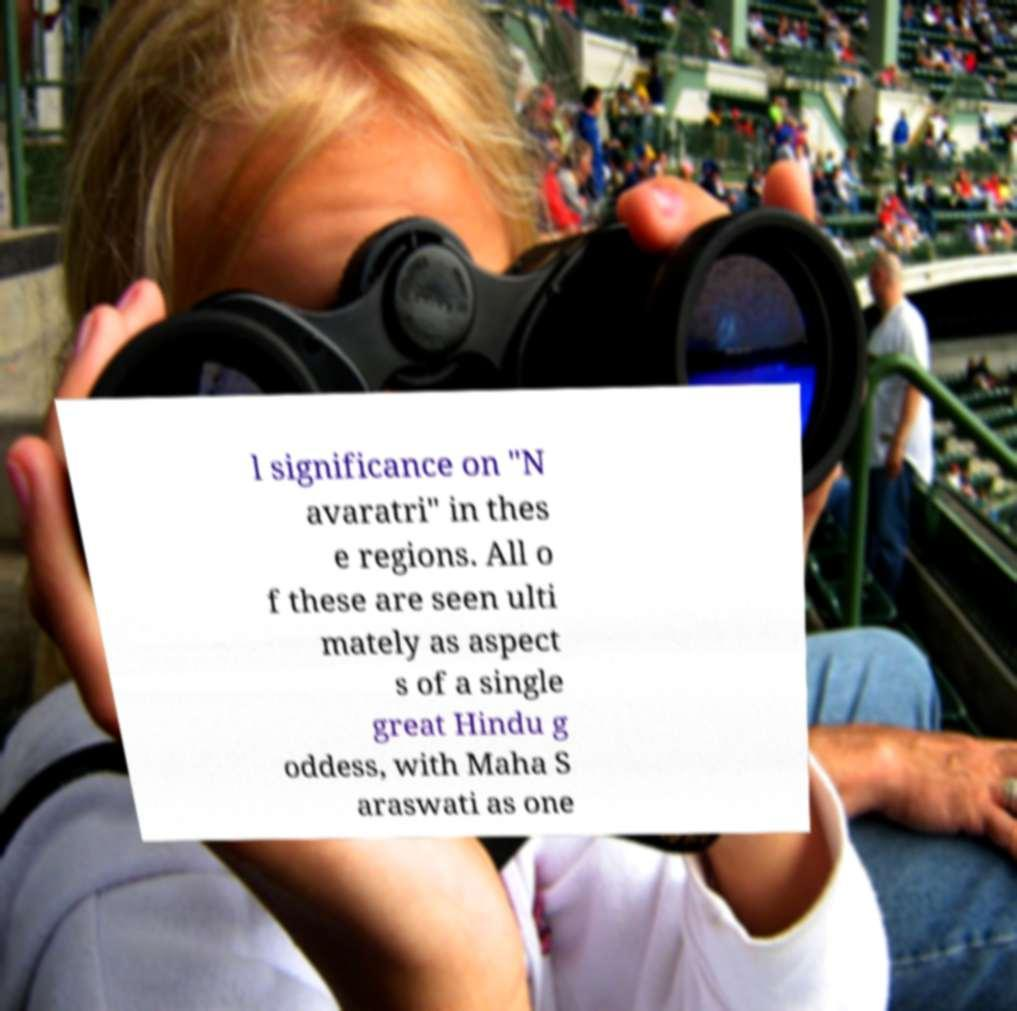Please identify and transcribe the text found in this image. l significance on "N avaratri" in thes e regions. All o f these are seen ulti mately as aspect s of a single great Hindu g oddess, with Maha S araswati as one 